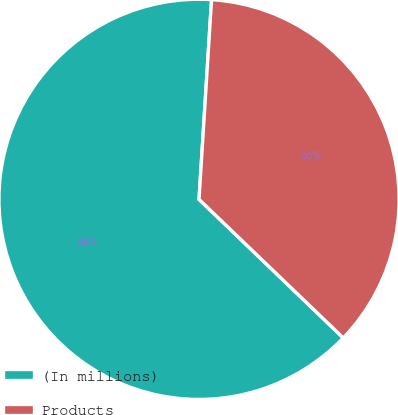<chart> <loc_0><loc_0><loc_500><loc_500><pie_chart><fcel>(In millions)<fcel>Products<nl><fcel>63.82%<fcel>36.18%<nl></chart> 